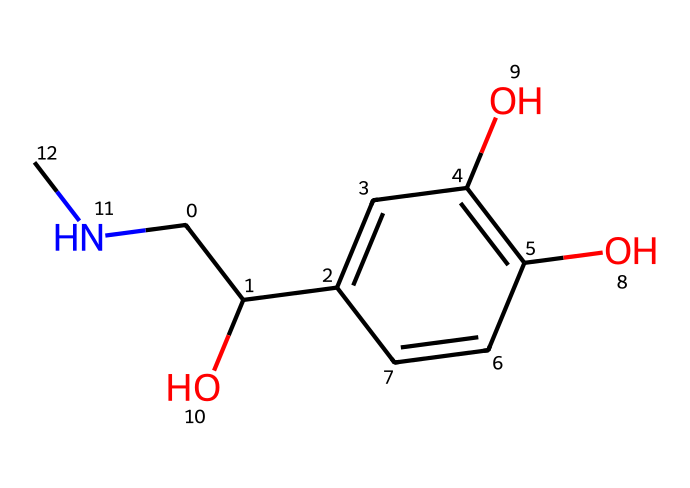What is the molecular formula of adrenaline? To determine the molecular formula, we count the number of each type of atom present in the structure shown by the SMILES. We find 9 carbon (C) atoms, 13 hydrogen (H) atoms, 1 nitrogen (N) atom, and 2 oxygen (O) atoms. Thus, the molecular formula is C9H13N1O2.
Answer: C9H13NO2 How many hydroxyl (-OH) groups are present in adrenaline? By examining the structure, we see two -OH groups attached to the aromatic ring and one -OH group attached to the aliphatic carbon, totaling three hydroxyl groups.
Answer: three What is the functional group present in adrenaline? Adrenaline contains amine and hydroxyl functional groups. The nitrogen atom (N) in the structure indicates the presence of an amine, and the -OH groups indicate alcohol (hydroxyl) functional groups.
Answer: amine and hydroxyl Which part of the adrenaline structure is responsible for its solubility in water? The presence of the hydroxyl (-OH) groups in adrenaline makes it polar, thus enhancing its solubility in water. The polar -OH groups interact favorably with water molecules.
Answer: hydroxyl groups How many rings are present in the adrenaline structure? From the SMILES representation, we can observe a single aromatic ring in the structure, which is identified by the presence of double bonds between carbon atoms in a cyclic form.
Answer: one What type of biological response is triggered by adrenaline? Adrenaline is known to facilitate the fight-or-flight response, which is a natural reaction to stress or danger resulting in increased heart rate, energy mobilization, and heightened awareness.
Answer: fight-or-flight response 